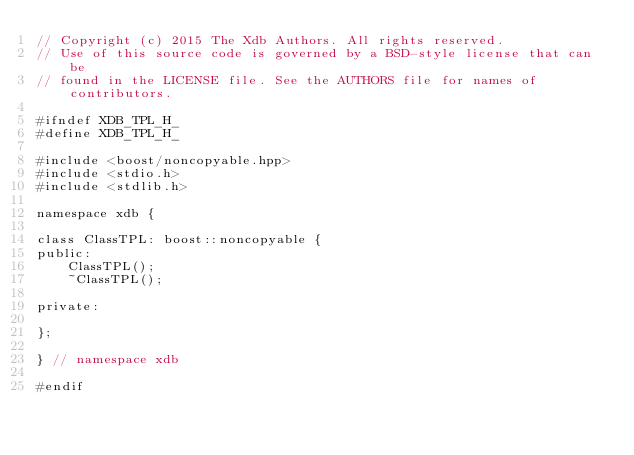Convert code to text. <code><loc_0><loc_0><loc_500><loc_500><_C_>// Copyright (c) 2015 The Xdb Authors. All rights reserved.
// Use of this source code is governed by a BSD-style license that can be
// found in the LICENSE file. See the AUTHORS file for names of contributors.

#ifndef XDB_TPL_H_
#define XDB_TPL_H_

#include <boost/noncopyable.hpp>
#include <stdio.h>
#include <stdlib.h>

namespace xdb {

class ClassTPL: boost::noncopyable {
public:
    ClassTPL();
    ~ClassTPL();

private:

};

} // namespace xdb

#endif

</code> 